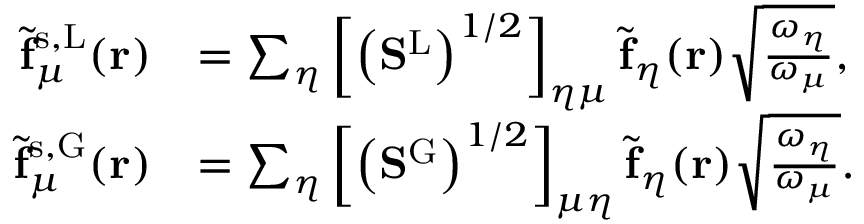<formula> <loc_0><loc_0><loc_500><loc_500>\begin{array} { r l } { \tilde { f } _ { \mu } ^ { s , L } ( r ) } & { = \sum _ { \eta } \left [ \left ( S ^ { L } \right ) ^ { 1 / 2 } \right ] _ { \eta \mu } \tilde { f } _ { \eta } ( r ) \sqrt { \frac { \omega _ { \eta } } { \omega _ { \mu } } } , } \\ { \tilde { f } _ { \mu } ^ { s , G } ( r ) } & { = \sum _ { \eta } \left [ \left ( S ^ { G } \right ) ^ { 1 / 2 } \right ] _ { \mu \eta } \tilde { f } _ { \eta } ( r ) \sqrt { \frac { \omega _ { \eta } } { \omega _ { \mu } } } . } \end{array}</formula> 